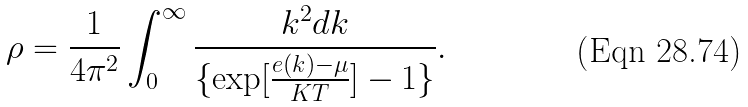Convert formula to latex. <formula><loc_0><loc_0><loc_500><loc_500>\rho = \frac { 1 } { 4 \pi ^ { 2 } } \int _ { 0 } ^ { \infty } \frac { k ^ { 2 } d k } { \{ \exp [ \frac { e ( k ) - \mu } { K T } ] - 1 \} } .</formula> 